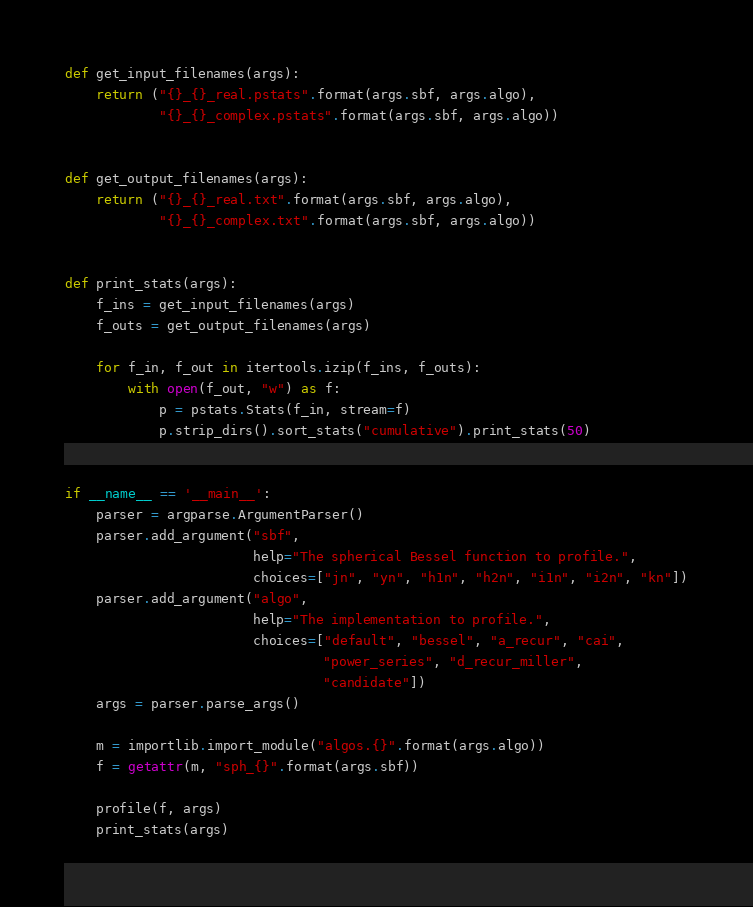<code> <loc_0><loc_0><loc_500><loc_500><_Python_>

def get_input_filenames(args):
    return ("{}_{}_real.pstats".format(args.sbf, args.algo),
            "{}_{}_complex.pstats".format(args.sbf, args.algo))


def get_output_filenames(args):
    return ("{}_{}_real.txt".format(args.sbf, args.algo),
            "{}_{}_complex.txt".format(args.sbf, args.algo))


def print_stats(args):
    f_ins = get_input_filenames(args)
    f_outs = get_output_filenames(args)

    for f_in, f_out in itertools.izip(f_ins, f_outs):
        with open(f_out, "w") as f:
            p = pstats.Stats(f_in, stream=f)
            p.strip_dirs().sort_stats("cumulative").print_stats(50)


if __name__ == '__main__':
    parser = argparse.ArgumentParser()
    parser.add_argument("sbf",
                        help="The spherical Bessel function to profile.",
                        choices=["jn", "yn", "h1n", "h2n", "i1n", "i2n", "kn"])
    parser.add_argument("algo",
                        help="The implementation to profile.",
                        choices=["default", "bessel", "a_recur", "cai",
                                 "power_series", "d_recur_miller",
                                 "candidate"])
    args = parser.parse_args()

    m = importlib.import_module("algos.{}".format(args.algo))
    f = getattr(m, "sph_{}".format(args.sbf))

    profile(f, args)
    print_stats(args)
</code> 